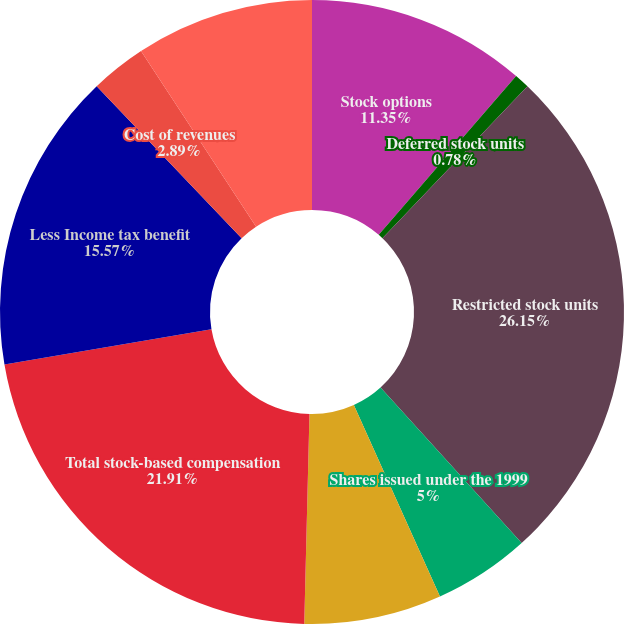Convert chart. <chart><loc_0><loc_0><loc_500><loc_500><pie_chart><fcel>Stock options<fcel>Deferred stock units<fcel>Restricted stock units<fcel>Shares issued under the 1999<fcel>Amounts capitalized as<fcel>Total stock-based compensation<fcel>Less Income tax benefit<fcel>Cost of revenues<fcel>Research and development<nl><fcel>11.35%<fcel>0.78%<fcel>26.14%<fcel>5.0%<fcel>7.12%<fcel>21.91%<fcel>15.57%<fcel>2.89%<fcel>9.23%<nl></chart> 